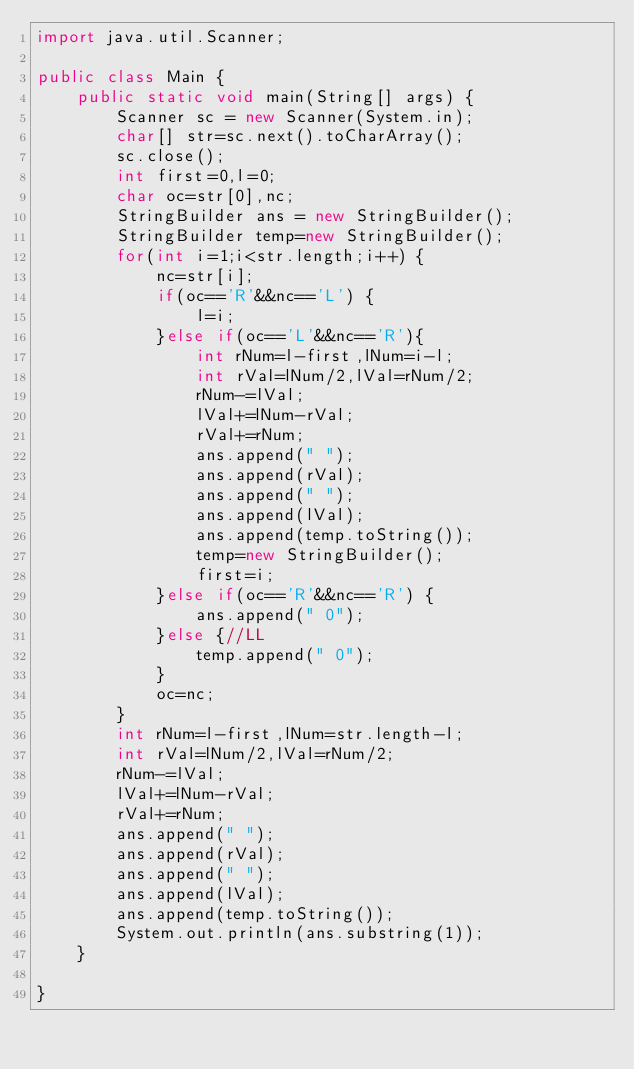<code> <loc_0><loc_0><loc_500><loc_500><_Java_>import java.util.Scanner;

public class Main {
	public static void main(String[] args) {
		Scanner sc = new Scanner(System.in);
		char[] str=sc.next().toCharArray();
		sc.close();
		int first=0,l=0;
		char oc=str[0],nc;
		StringBuilder ans = new StringBuilder();
		StringBuilder temp=new StringBuilder();
		for(int i=1;i<str.length;i++) {
			nc=str[i];
			if(oc=='R'&&nc=='L') {
				l=i;
			}else if(oc=='L'&&nc=='R'){
				int rNum=l-first,lNum=i-l;
				int rVal=lNum/2,lVal=rNum/2;
				rNum-=lVal;
				lVal+=lNum-rVal;
				rVal+=rNum;
				ans.append(" ");
				ans.append(rVal);
				ans.append(" ");
				ans.append(lVal);
				ans.append(temp.toString());
				temp=new StringBuilder();
				first=i;
			}else if(oc=='R'&&nc=='R') {
				ans.append(" 0");
			}else {//LL
				temp.append(" 0");
			}
			oc=nc;
		}
		int rNum=l-first,lNum=str.length-l;
		int rVal=lNum/2,lVal=rNum/2;
		rNum-=lVal;
		lVal+=lNum-rVal;
		rVal+=rNum;
		ans.append(" ");
		ans.append(rVal);
		ans.append(" ");
		ans.append(lVal);
		ans.append(temp.toString());
		System.out.println(ans.substring(1));
	}

}
</code> 